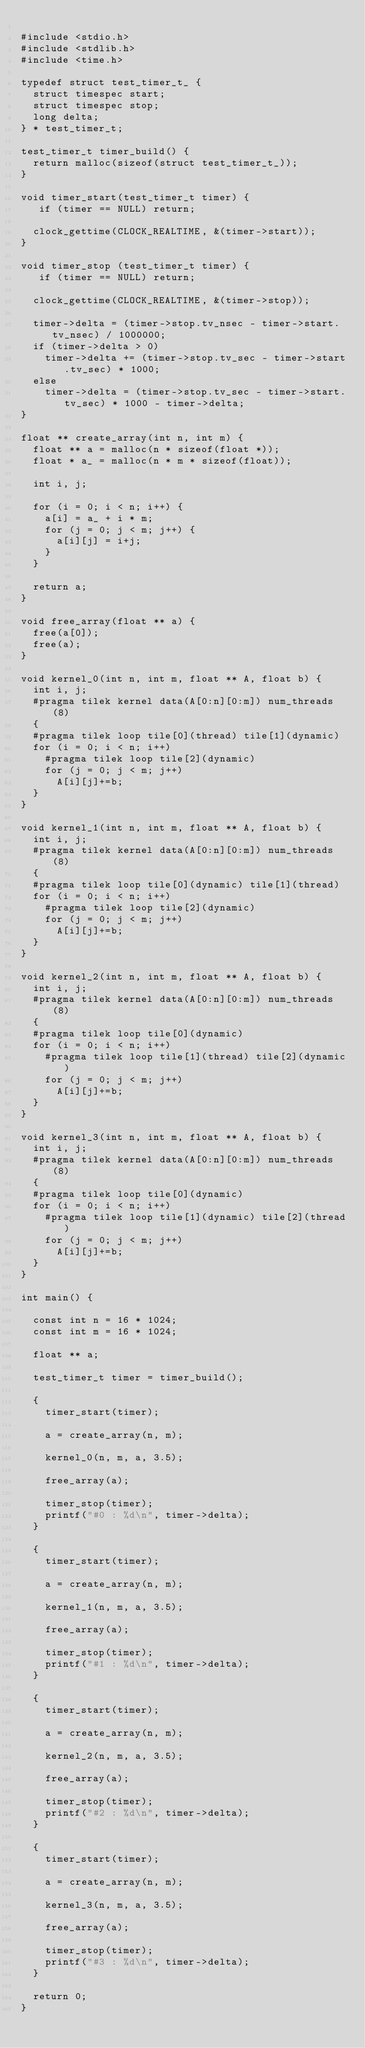Convert code to text. <code><loc_0><loc_0><loc_500><loc_500><_C_>
#include <stdio.h>
#include <stdlib.h>
#include <time.h>

typedef struct test_timer_t_ {
  struct timespec start;
  struct timespec stop;
  long delta;
} * test_timer_t;

test_timer_t timer_build() {
  return malloc(sizeof(struct test_timer_t_));
}

void timer_start(test_timer_t timer) {
   if (timer == NULL) return;

  clock_gettime(CLOCK_REALTIME, &(timer->start));
}

void timer_stop (test_timer_t timer) {
   if (timer == NULL) return;

  clock_gettime(CLOCK_REALTIME, &(timer->stop));

  timer->delta = (timer->stop.tv_nsec - timer->start.tv_nsec) / 1000000;
  if (timer->delta > 0)
    timer->delta += (timer->stop.tv_sec - timer->start.tv_sec) * 1000;
  else
    timer->delta = (timer->stop.tv_sec - timer->start.tv_sec) * 1000 - timer->delta;
}

float ** create_array(int n, int m) {
  float ** a = malloc(n * sizeof(float *));
  float * a_ = malloc(n * m * sizeof(float));

  int i, j;

  for (i = 0; i < n; i++) {
    a[i] = a_ + i * m;
    for (j = 0; j < m; j++) {
      a[i][j] = i+j;
    }
  }

  return a;
}

void free_array(float ** a) {
  free(a[0]);
  free(a);
}

void kernel_0(int n, int m, float ** A, float b) {
  int i, j;
  #pragma tilek kernel data(A[0:n][0:m]) num_threads(8)
  {
  #pragma tilek loop tile[0](thread) tile[1](dynamic)
  for (i = 0; i < n; i++)
    #pragma tilek loop tile[2](dynamic)
    for (j = 0; j < m; j++)
      A[i][j]+=b;
  }
}

void kernel_1(int n, int m, float ** A, float b) {
  int i, j;
  #pragma tilek kernel data(A[0:n][0:m]) num_threads(8)
  {
  #pragma tilek loop tile[0](dynamic) tile[1](thread)
  for (i = 0; i < n; i++)
    #pragma tilek loop tile[2](dynamic)
    for (j = 0; j < m; j++)
      A[i][j]+=b;
  }
}

void kernel_2(int n, int m, float ** A, float b) {
  int i, j;
  #pragma tilek kernel data(A[0:n][0:m]) num_threads(8)
  {
  #pragma tilek loop tile[0](dynamic)
  for (i = 0; i < n; i++)
    #pragma tilek loop tile[1](thread) tile[2](dynamic)
    for (j = 0; j < m; j++)
      A[i][j]+=b;
  }
}

void kernel_3(int n, int m, float ** A, float b) {
  int i, j;
  #pragma tilek kernel data(A[0:n][0:m]) num_threads(8)
  {
  #pragma tilek loop tile[0](dynamic)
  for (i = 0; i < n; i++)
    #pragma tilek loop tile[1](dynamic) tile[2](thread)
    for (j = 0; j < m; j++)
      A[i][j]+=b;
  }
}

int main() {

  const int n = 16 * 1024;
  const int m = 16 * 1024;

  float ** a;

  test_timer_t timer = timer_build();

  {
    timer_start(timer);

    a = create_array(n, m);

    kernel_0(n, m, a, 3.5);

    free_array(a);

    timer_stop(timer);
    printf("#0 : %d\n", timer->delta);
  }

  {
    timer_start(timer);

    a = create_array(n, m);

    kernel_1(n, m, a, 3.5);

    free_array(a);

    timer_stop(timer);
    printf("#1 : %d\n", timer->delta);
  }

  {
    timer_start(timer);

    a = create_array(n, m);

    kernel_2(n, m, a, 3.5);

    free_array(a);

    timer_stop(timer);
    printf("#2 : %d\n", timer->delta);
  }

  {
    timer_start(timer);

    a = create_array(n, m);

    kernel_3(n, m, a, 3.5);

    free_array(a);

    timer_stop(timer);
    printf("#3 : %d\n", timer->delta);
  }

  return 0;
}

</code> 